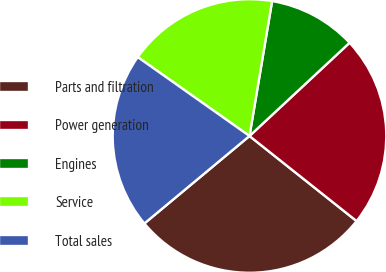Convert chart. <chart><loc_0><loc_0><loc_500><loc_500><pie_chart><fcel>Parts and filtration<fcel>Power generation<fcel>Engines<fcel>Service<fcel>Total sales<nl><fcel>28.27%<fcel>22.62%<fcel>10.42%<fcel>17.86%<fcel>20.83%<nl></chart> 